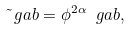<formula> <loc_0><loc_0><loc_500><loc_500>\tilde { \ } g a b = \phi ^ { 2 \alpha } \ g a b ,</formula> 